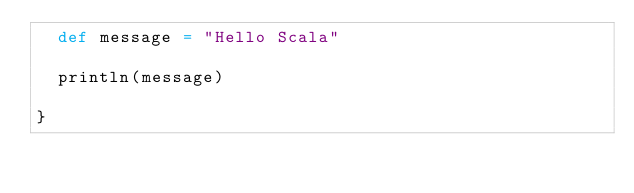Convert code to text. <code><loc_0><loc_0><loc_500><loc_500><_Scala_>  def message = "Hello Scala"
    
  println(message)  
  
}</code> 